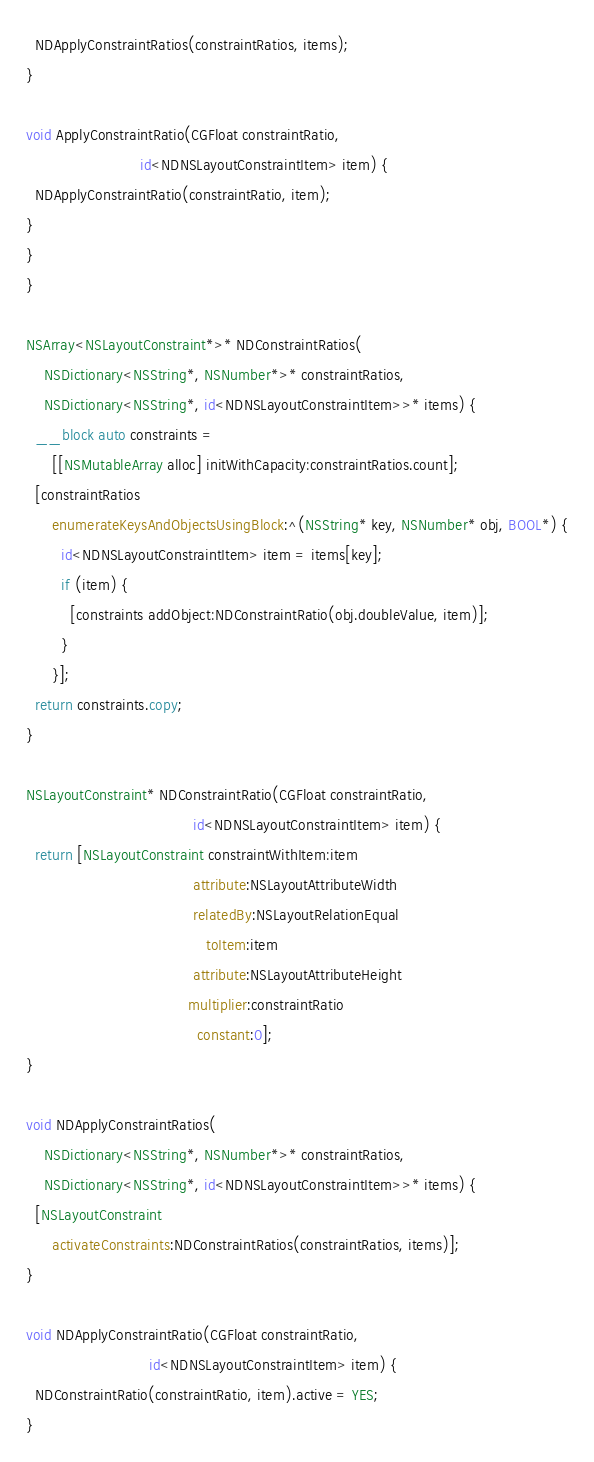Convert code to text. <code><loc_0><loc_0><loc_500><loc_500><_ObjectiveC_>  NDApplyConstraintRatios(constraintRatios, items);
}

void ApplyConstraintRatio(CGFloat constraintRatio,
                          id<NDNSLayoutConstraintItem> item) {
  NDApplyConstraintRatio(constraintRatio, item);
}
}
}

NSArray<NSLayoutConstraint*>* NDConstraintRatios(
    NSDictionary<NSString*, NSNumber*>* constraintRatios,
    NSDictionary<NSString*, id<NDNSLayoutConstraintItem>>* items) {
  __block auto constraints =
      [[NSMutableArray alloc] initWithCapacity:constraintRatios.count];
  [constraintRatios
      enumerateKeysAndObjectsUsingBlock:^(NSString* key, NSNumber* obj, BOOL*) {
        id<NDNSLayoutConstraintItem> item = items[key];
        if (item) {
          [constraints addObject:NDConstraintRatio(obj.doubleValue, item)];
        }
      }];
  return constraints.copy;
}

NSLayoutConstraint* NDConstraintRatio(CGFloat constraintRatio,
                                      id<NDNSLayoutConstraintItem> item) {
  return [NSLayoutConstraint constraintWithItem:item
                                      attribute:NSLayoutAttributeWidth
                                      relatedBy:NSLayoutRelationEqual
                                         toItem:item
                                      attribute:NSLayoutAttributeHeight
                                     multiplier:constraintRatio
                                       constant:0];
}

void NDApplyConstraintRatios(
    NSDictionary<NSString*, NSNumber*>* constraintRatios,
    NSDictionary<NSString*, id<NDNSLayoutConstraintItem>>* items) {
  [NSLayoutConstraint
      activateConstraints:NDConstraintRatios(constraintRatios, items)];
}

void NDApplyConstraintRatio(CGFloat constraintRatio,
                            id<NDNSLayoutConstraintItem> item) {
  NDConstraintRatio(constraintRatio, item).active = YES;
}
</code> 